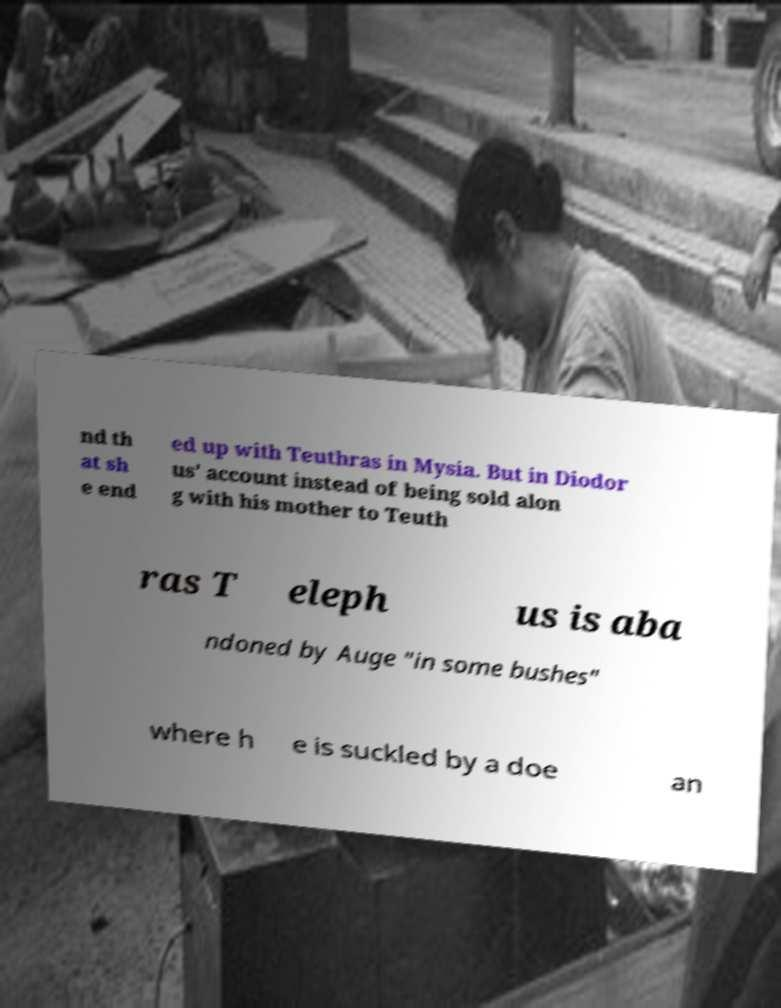Could you extract and type out the text from this image? nd th at sh e end ed up with Teuthras in Mysia. But in Diodor us' account instead of being sold alon g with his mother to Teuth ras T eleph us is aba ndoned by Auge "in some bushes" where h e is suckled by a doe an 